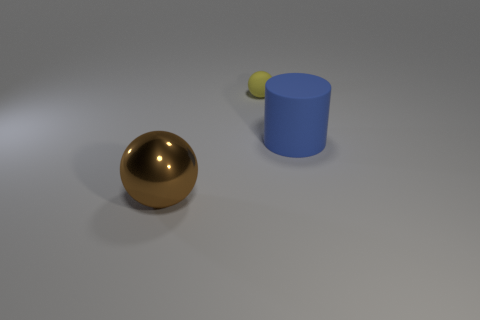Is there anything else that has the same material as the brown sphere?
Make the answer very short. No. What number of things are either rubber objects that are to the left of the blue thing or spheres in front of the big blue rubber cylinder?
Provide a short and direct response. 2. There is a matte thing behind the blue rubber cylinder; does it have the same size as the brown shiny object?
Your answer should be compact. No. What size is the yellow thing that is the same shape as the big brown shiny object?
Provide a short and direct response. Small. What is the material of the brown object that is the same size as the rubber cylinder?
Offer a very short reply. Metal. What material is the other object that is the same shape as the large metal thing?
Your answer should be compact. Rubber. What number of other things are there of the same size as the matte sphere?
Ensure brevity in your answer.  0. What number of tiny rubber things have the same color as the shiny thing?
Make the answer very short. 0. There is a yellow matte thing; what shape is it?
Provide a short and direct response. Sphere. There is a thing that is both on the left side of the big blue cylinder and in front of the small matte sphere; what color is it?
Make the answer very short. Brown. 